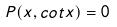<formula> <loc_0><loc_0><loc_500><loc_500>P ( x , c o t x ) = 0</formula> 